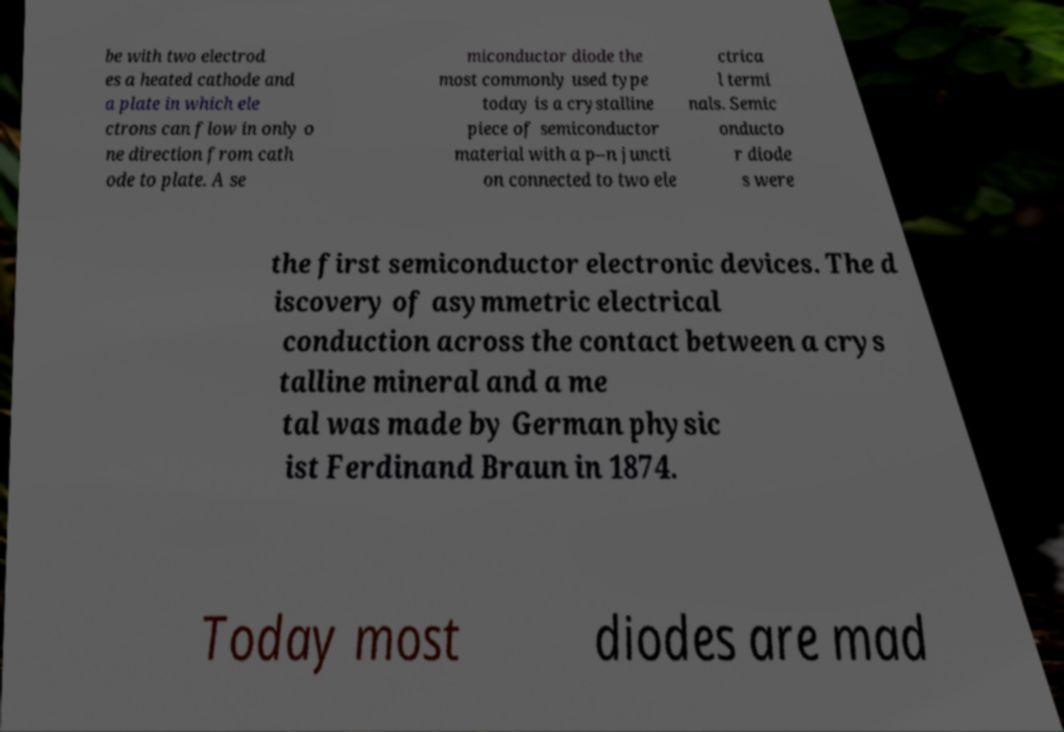For documentation purposes, I need the text within this image transcribed. Could you provide that? be with two electrod es a heated cathode and a plate in which ele ctrons can flow in only o ne direction from cath ode to plate. A se miconductor diode the most commonly used type today is a crystalline piece of semiconductor material with a p–n juncti on connected to two ele ctrica l termi nals. Semic onducto r diode s were the first semiconductor electronic devices. The d iscovery of asymmetric electrical conduction across the contact between a crys talline mineral and a me tal was made by German physic ist Ferdinand Braun in 1874. Today most diodes are mad 